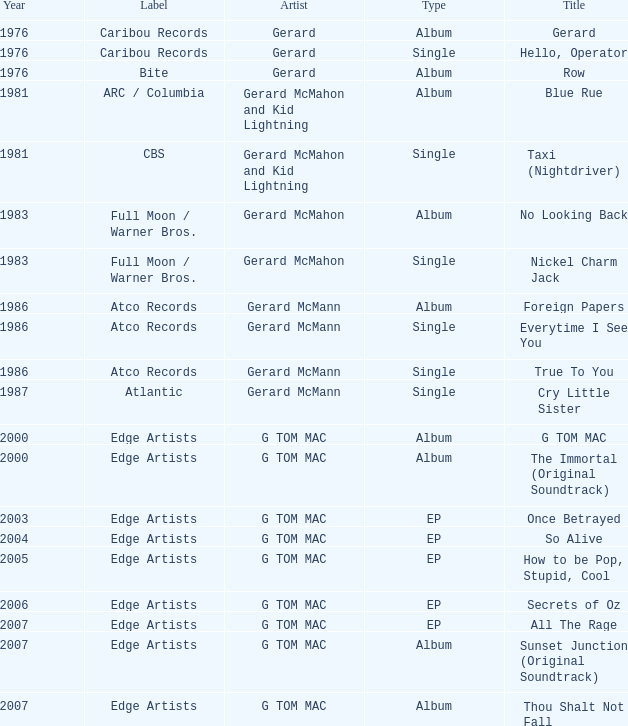Can you give me this table as a dict? {'header': ['Year', 'Label', 'Artist', 'Type', 'Title'], 'rows': [['1976', 'Caribou Records', 'Gerard', 'Album', 'Gerard'], ['1976', 'Caribou Records', 'Gerard', 'Single', 'Hello, Operator'], ['1976', 'Bite', 'Gerard', 'Album', 'Row'], ['1981', 'ARC / Columbia', 'Gerard McMahon and Kid Lightning', 'Album', 'Blue Rue'], ['1981', 'CBS', 'Gerard McMahon and Kid Lightning', 'Single', 'Taxi (Nightdriver)'], ['1983', 'Full Moon / Warner Bros.', 'Gerard McMahon', 'Album', 'No Looking Back'], ['1983', 'Full Moon / Warner Bros.', 'Gerard McMahon', 'Single', 'Nickel Charm Jack'], ['1986', 'Atco Records', 'Gerard McMann', 'Album', 'Foreign Papers'], ['1986', 'Atco Records', 'Gerard McMann', 'Single', 'Everytime I See You'], ['1986', 'Atco Records', 'Gerard McMann', 'Single', 'True To You'], ['1987', 'Atlantic', 'Gerard McMann', 'Single', 'Cry Little Sister'], ['2000', 'Edge Artists', 'G TOM MAC', 'Album', 'G TOM MAC'], ['2000', 'Edge Artists', 'G TOM MAC', 'Album', 'The Immortal (Original Soundtrack)'], ['2003', 'Edge Artists', 'G TOM MAC', 'EP', 'Once Betrayed'], ['2004', 'Edge Artists', 'G TOM MAC', 'EP', 'So Alive'], ['2005', 'Edge Artists', 'G TOM MAC', 'EP', 'How to be Pop, Stupid, Cool'], ['2006', 'Edge Artists', 'G TOM MAC', 'EP', 'Secrets of Oz'], ['2007', 'Edge Artists', 'G TOM MAC', 'EP', 'All The Rage'], ['2007', 'Edge Artists', 'G TOM MAC', 'Album', 'Sunset Junction (Original Soundtrack)'], ['2007', 'Edge Artists', 'G TOM MAC', 'Album', 'Thou Shalt Not Fall']]} Which Title has a Type of album in 1983? No Looking Back. 